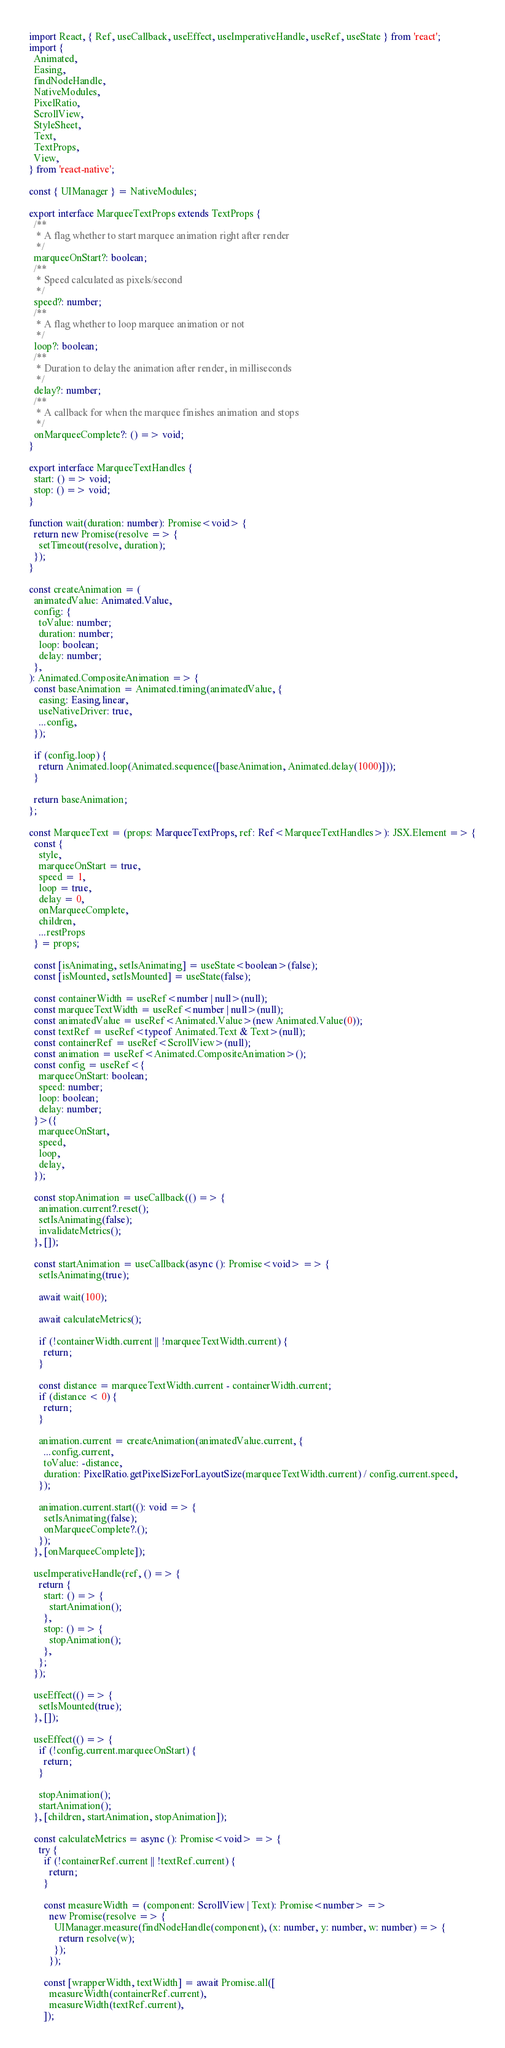<code> <loc_0><loc_0><loc_500><loc_500><_TypeScript_>import React, { Ref, useCallback, useEffect, useImperativeHandle, useRef, useState } from 'react';
import {
  Animated,
  Easing,
  findNodeHandle,
  NativeModules,
  PixelRatio,
  ScrollView,
  StyleSheet,
  Text,
  TextProps,
  View,
} from 'react-native';

const { UIManager } = NativeModules;

export interface MarqueeTextProps extends TextProps {
  /**
   * A flag whether to start marquee animation right after render
   */
  marqueeOnStart?: boolean;
  /**
   * Speed calculated as pixels/second
   */
  speed?: number;
  /**
   * A flag whether to loop marquee animation or not
   */
  loop?: boolean;
  /**
   * Duration to delay the animation after render, in milliseconds
   */
  delay?: number;
  /**
   * A callback for when the marquee finishes animation and stops
   */
  onMarqueeComplete?: () => void;
}

export interface MarqueeTextHandles {
  start: () => void;
  stop: () => void;
}

function wait(duration: number): Promise<void> {
  return new Promise(resolve => {
    setTimeout(resolve, duration);
  });
}

const createAnimation = (
  animatedValue: Animated.Value,
  config: {
    toValue: number;
    duration: number;
    loop: boolean;
    delay: number;
  },
): Animated.CompositeAnimation => {
  const baseAnimation = Animated.timing(animatedValue, {
    easing: Easing.linear,
    useNativeDriver: true,
    ...config,
  });

  if (config.loop) {
    return Animated.loop(Animated.sequence([baseAnimation, Animated.delay(1000)]));
  }

  return baseAnimation;
};

const MarqueeText = (props: MarqueeTextProps, ref: Ref<MarqueeTextHandles>): JSX.Element => {
  const {
    style,
    marqueeOnStart = true,
    speed = 1,
    loop = true,
    delay = 0,
    onMarqueeComplete,
    children,
    ...restProps
  } = props;

  const [isAnimating, setIsAnimating] = useState<boolean>(false);
  const [isMounted, setIsMounted] = useState(false);

  const containerWidth = useRef<number | null>(null);
  const marqueeTextWidth = useRef<number | null>(null);
  const animatedValue = useRef<Animated.Value>(new Animated.Value(0));
  const textRef = useRef<typeof Animated.Text & Text>(null);
  const containerRef = useRef<ScrollView>(null);
  const animation = useRef<Animated.CompositeAnimation>();
  const config = useRef<{
    marqueeOnStart: boolean;
    speed: number;
    loop: boolean;
    delay: number;
  }>({
    marqueeOnStart,
    speed,
    loop,
    delay,
  });

  const stopAnimation = useCallback(() => {
    animation.current?.reset();
    setIsAnimating(false);
    invalidateMetrics();
  }, []);

  const startAnimation = useCallback(async (): Promise<void> => {
    setIsAnimating(true);

    await wait(100);

    await calculateMetrics();

    if (!containerWidth.current || !marqueeTextWidth.current) {
      return;
    }

    const distance = marqueeTextWidth.current - containerWidth.current;
    if (distance < 0) {
      return;
    }

    animation.current = createAnimation(animatedValue.current, {
      ...config.current,
      toValue: -distance,
      duration: PixelRatio.getPixelSizeForLayoutSize(marqueeTextWidth.current) / config.current.speed,
    });

    animation.current.start((): void => {
      setIsAnimating(false);
      onMarqueeComplete?.();
    });
  }, [onMarqueeComplete]);

  useImperativeHandle(ref, () => {
    return {
      start: () => {
        startAnimation();
      },
      stop: () => {
        stopAnimation();
      },
    };
  });

  useEffect(() => {
    setIsMounted(true);
  }, []);

  useEffect(() => {
    if (!config.current.marqueeOnStart) {
      return;
    }

    stopAnimation();
    startAnimation();
  }, [children, startAnimation, stopAnimation]);

  const calculateMetrics = async (): Promise<void> => {
    try {
      if (!containerRef.current || !textRef.current) {
        return;
      }

      const measureWidth = (component: ScrollView | Text): Promise<number> =>
        new Promise(resolve => {
          UIManager.measure(findNodeHandle(component), (x: number, y: number, w: number) => {
            return resolve(w);
          });
        });

      const [wrapperWidth, textWidth] = await Promise.all([
        measureWidth(containerRef.current),
        measureWidth(textRef.current),
      ]);
</code> 